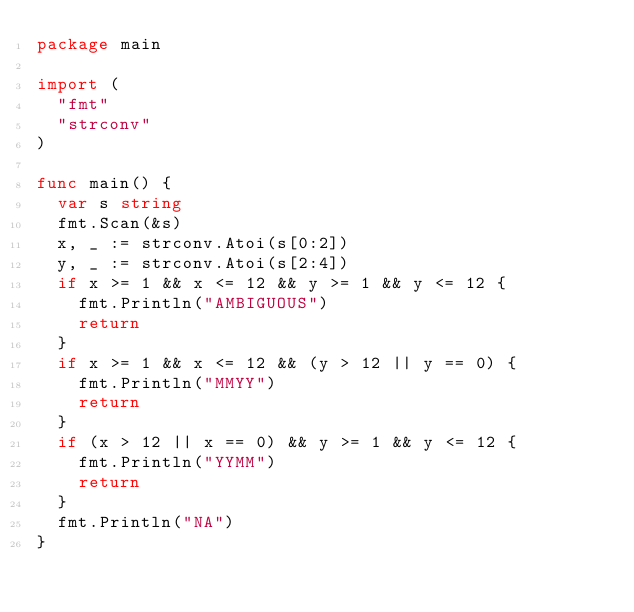Convert code to text. <code><loc_0><loc_0><loc_500><loc_500><_Go_>package main

import (
	"fmt"
	"strconv"
)

func main() {
	var s string
	fmt.Scan(&s)
	x, _ := strconv.Atoi(s[0:2])
	y, _ := strconv.Atoi(s[2:4])
	if x >= 1 && x <= 12 && y >= 1 && y <= 12 {
		fmt.Println("AMBIGUOUS")
		return
	}
	if x >= 1 && x <= 12 && (y > 12 || y == 0) {
		fmt.Println("MMYY")
		return
	}
	if (x > 12 || x == 0) && y >= 1 && y <= 12 {
		fmt.Println("YYMM")
		return
	}
	fmt.Println("NA")
}
</code> 